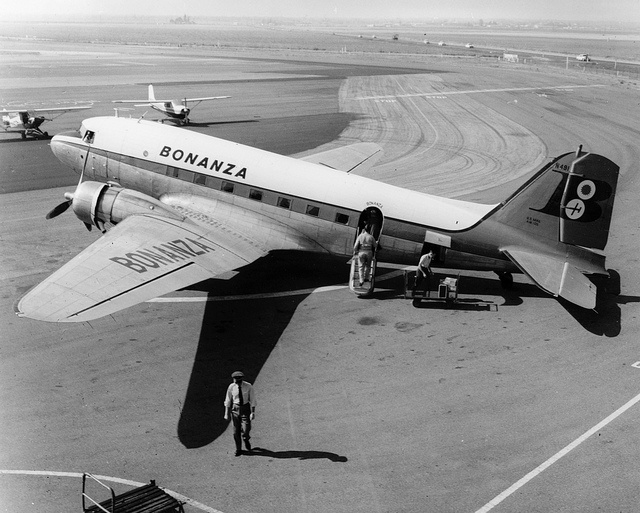Describe the objects in this image and their specific colors. I can see airplane in white, lightgray, darkgray, gray, and black tones, people in white, black, gray, darkgray, and lightgray tones, airplane in white, darkgray, black, gray, and gainsboro tones, airplane in white, lightgray, darkgray, gray, and black tones, and people in white, black, gray, darkgray, and lightgray tones in this image. 